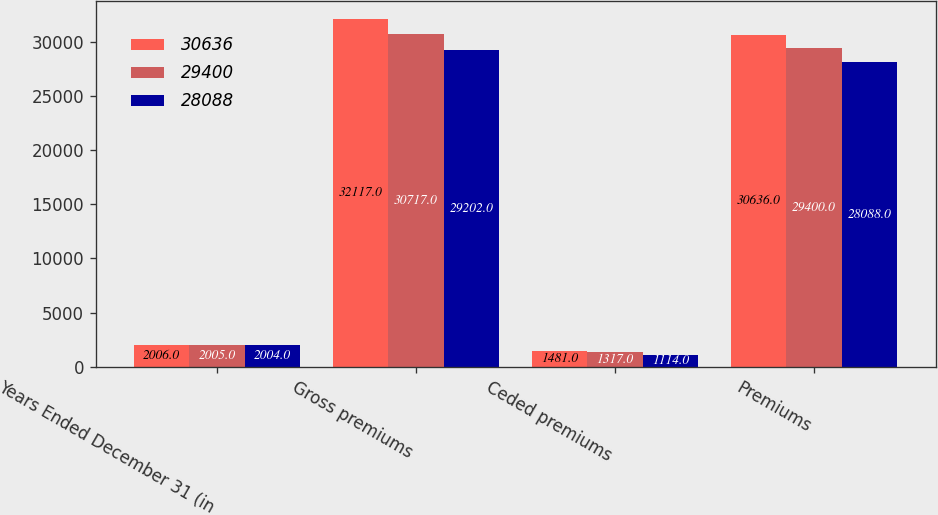Convert chart to OTSL. <chart><loc_0><loc_0><loc_500><loc_500><stacked_bar_chart><ecel><fcel>Years Ended December 31 (in<fcel>Gross premiums<fcel>Ceded premiums<fcel>Premiums<nl><fcel>30636<fcel>2006<fcel>32117<fcel>1481<fcel>30636<nl><fcel>29400<fcel>2005<fcel>30717<fcel>1317<fcel>29400<nl><fcel>28088<fcel>2004<fcel>29202<fcel>1114<fcel>28088<nl></chart> 